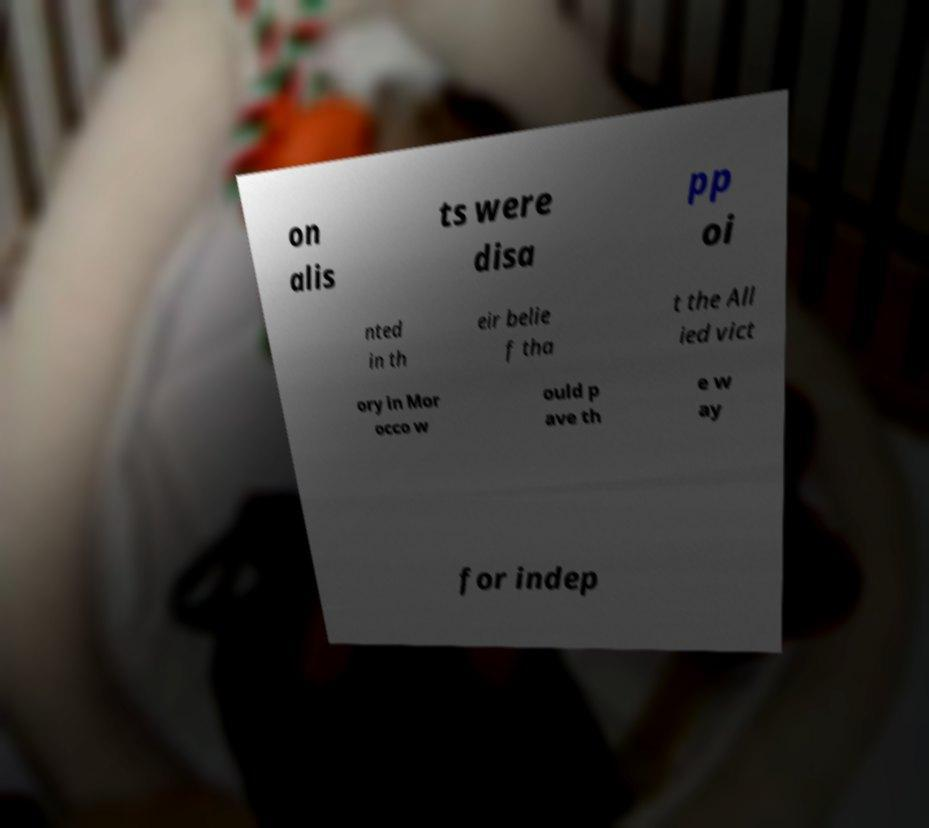Can you read and provide the text displayed in the image?This photo seems to have some interesting text. Can you extract and type it out for me? on alis ts were disa pp oi nted in th eir belie f tha t the All ied vict ory in Mor occo w ould p ave th e w ay for indep 